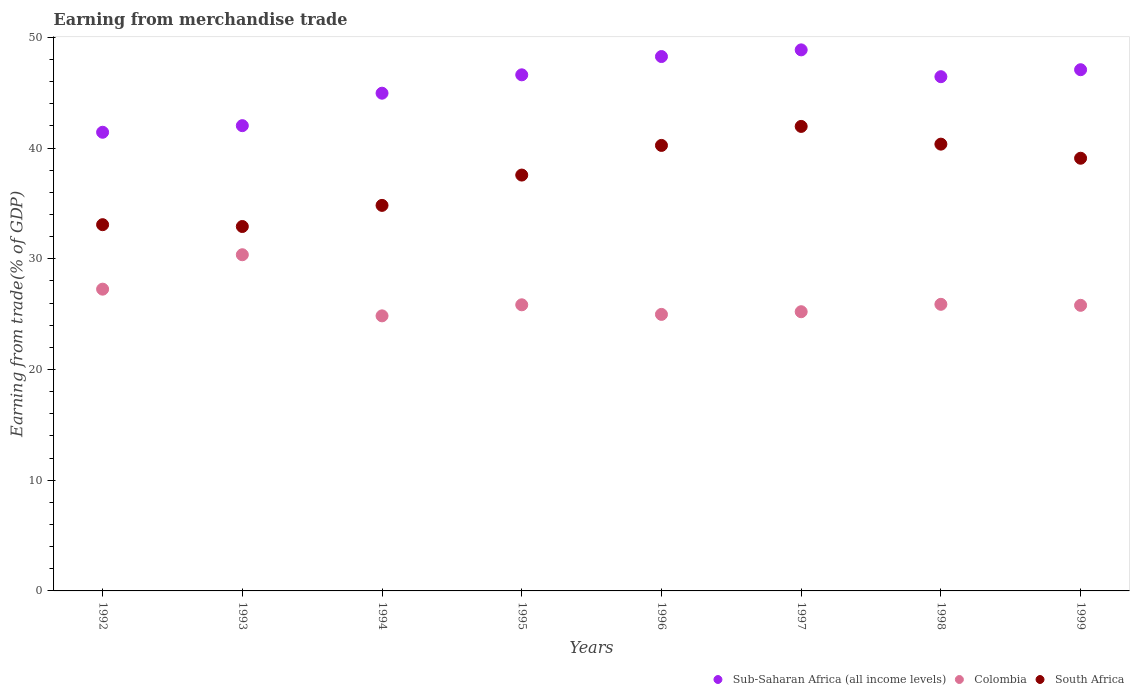What is the earnings from trade in Sub-Saharan Africa (all income levels) in 1996?
Provide a succinct answer. 48.27. Across all years, what is the maximum earnings from trade in Colombia?
Your answer should be compact. 30.37. Across all years, what is the minimum earnings from trade in Colombia?
Your answer should be very brief. 24.85. In which year was the earnings from trade in Colombia maximum?
Offer a very short reply. 1993. What is the total earnings from trade in South Africa in the graph?
Your response must be concise. 300.04. What is the difference between the earnings from trade in Colombia in 1994 and that in 1995?
Offer a terse response. -1. What is the difference between the earnings from trade in South Africa in 1997 and the earnings from trade in Colombia in 1996?
Keep it short and to the point. 16.98. What is the average earnings from trade in Sub-Saharan Africa (all income levels) per year?
Your answer should be compact. 45.71. In the year 1996, what is the difference between the earnings from trade in Sub-Saharan Africa (all income levels) and earnings from trade in Colombia?
Provide a succinct answer. 23.29. In how many years, is the earnings from trade in South Africa greater than 4 %?
Offer a terse response. 8. What is the ratio of the earnings from trade in Sub-Saharan Africa (all income levels) in 1992 to that in 1995?
Provide a succinct answer. 0.89. What is the difference between the highest and the second highest earnings from trade in South Africa?
Provide a succinct answer. 1.6. What is the difference between the highest and the lowest earnings from trade in Sub-Saharan Africa (all income levels)?
Make the answer very short. 7.44. In how many years, is the earnings from trade in Sub-Saharan Africa (all income levels) greater than the average earnings from trade in Sub-Saharan Africa (all income levels) taken over all years?
Keep it short and to the point. 5. Is it the case that in every year, the sum of the earnings from trade in South Africa and earnings from trade in Sub-Saharan Africa (all income levels)  is greater than the earnings from trade in Colombia?
Offer a terse response. Yes. What is the difference between two consecutive major ticks on the Y-axis?
Give a very brief answer. 10. How many legend labels are there?
Offer a terse response. 3. How are the legend labels stacked?
Keep it short and to the point. Horizontal. What is the title of the graph?
Provide a succinct answer. Earning from merchandise trade. Does "Togo" appear as one of the legend labels in the graph?
Your response must be concise. No. What is the label or title of the X-axis?
Keep it short and to the point. Years. What is the label or title of the Y-axis?
Provide a succinct answer. Earning from trade(% of GDP). What is the Earning from trade(% of GDP) in Sub-Saharan Africa (all income levels) in 1992?
Your answer should be compact. 41.43. What is the Earning from trade(% of GDP) in Colombia in 1992?
Make the answer very short. 27.26. What is the Earning from trade(% of GDP) in South Africa in 1992?
Your answer should be compact. 33.08. What is the Earning from trade(% of GDP) of Sub-Saharan Africa (all income levels) in 1993?
Your answer should be compact. 42.03. What is the Earning from trade(% of GDP) in Colombia in 1993?
Offer a terse response. 30.37. What is the Earning from trade(% of GDP) of South Africa in 1993?
Offer a very short reply. 32.92. What is the Earning from trade(% of GDP) in Sub-Saharan Africa (all income levels) in 1994?
Your answer should be compact. 44.96. What is the Earning from trade(% of GDP) in Colombia in 1994?
Offer a very short reply. 24.85. What is the Earning from trade(% of GDP) of South Africa in 1994?
Provide a short and direct response. 34.83. What is the Earning from trade(% of GDP) of Sub-Saharan Africa (all income levels) in 1995?
Your answer should be very brief. 46.62. What is the Earning from trade(% of GDP) in Colombia in 1995?
Provide a succinct answer. 25.85. What is the Earning from trade(% of GDP) of South Africa in 1995?
Your answer should be compact. 37.57. What is the Earning from trade(% of GDP) in Sub-Saharan Africa (all income levels) in 1996?
Make the answer very short. 48.27. What is the Earning from trade(% of GDP) of Colombia in 1996?
Make the answer very short. 24.98. What is the Earning from trade(% of GDP) of South Africa in 1996?
Make the answer very short. 40.24. What is the Earning from trade(% of GDP) of Sub-Saharan Africa (all income levels) in 1997?
Provide a short and direct response. 48.87. What is the Earning from trade(% of GDP) of Colombia in 1997?
Offer a very short reply. 25.22. What is the Earning from trade(% of GDP) in South Africa in 1997?
Offer a very short reply. 41.96. What is the Earning from trade(% of GDP) of Sub-Saharan Africa (all income levels) in 1998?
Offer a terse response. 46.45. What is the Earning from trade(% of GDP) of Colombia in 1998?
Give a very brief answer. 25.89. What is the Earning from trade(% of GDP) in South Africa in 1998?
Provide a short and direct response. 40.36. What is the Earning from trade(% of GDP) in Sub-Saharan Africa (all income levels) in 1999?
Provide a short and direct response. 47.08. What is the Earning from trade(% of GDP) of Colombia in 1999?
Your answer should be compact. 25.8. What is the Earning from trade(% of GDP) of South Africa in 1999?
Provide a short and direct response. 39.09. Across all years, what is the maximum Earning from trade(% of GDP) in Sub-Saharan Africa (all income levels)?
Your response must be concise. 48.87. Across all years, what is the maximum Earning from trade(% of GDP) of Colombia?
Make the answer very short. 30.37. Across all years, what is the maximum Earning from trade(% of GDP) of South Africa?
Your answer should be very brief. 41.96. Across all years, what is the minimum Earning from trade(% of GDP) in Sub-Saharan Africa (all income levels)?
Ensure brevity in your answer.  41.43. Across all years, what is the minimum Earning from trade(% of GDP) in Colombia?
Provide a short and direct response. 24.85. Across all years, what is the minimum Earning from trade(% of GDP) of South Africa?
Keep it short and to the point. 32.92. What is the total Earning from trade(% of GDP) of Sub-Saharan Africa (all income levels) in the graph?
Provide a short and direct response. 365.72. What is the total Earning from trade(% of GDP) in Colombia in the graph?
Provide a short and direct response. 210.21. What is the total Earning from trade(% of GDP) of South Africa in the graph?
Make the answer very short. 300.04. What is the difference between the Earning from trade(% of GDP) of Sub-Saharan Africa (all income levels) in 1992 and that in 1993?
Your response must be concise. -0.6. What is the difference between the Earning from trade(% of GDP) of Colombia in 1992 and that in 1993?
Make the answer very short. -3.11. What is the difference between the Earning from trade(% of GDP) in South Africa in 1992 and that in 1993?
Make the answer very short. 0.16. What is the difference between the Earning from trade(% of GDP) in Sub-Saharan Africa (all income levels) in 1992 and that in 1994?
Ensure brevity in your answer.  -3.53. What is the difference between the Earning from trade(% of GDP) in Colombia in 1992 and that in 1994?
Provide a short and direct response. 2.41. What is the difference between the Earning from trade(% of GDP) in South Africa in 1992 and that in 1994?
Your answer should be compact. -1.74. What is the difference between the Earning from trade(% of GDP) in Sub-Saharan Africa (all income levels) in 1992 and that in 1995?
Offer a terse response. -5.19. What is the difference between the Earning from trade(% of GDP) of Colombia in 1992 and that in 1995?
Ensure brevity in your answer.  1.41. What is the difference between the Earning from trade(% of GDP) in South Africa in 1992 and that in 1995?
Give a very brief answer. -4.48. What is the difference between the Earning from trade(% of GDP) of Sub-Saharan Africa (all income levels) in 1992 and that in 1996?
Give a very brief answer. -6.84. What is the difference between the Earning from trade(% of GDP) in Colombia in 1992 and that in 1996?
Provide a succinct answer. 2.28. What is the difference between the Earning from trade(% of GDP) in South Africa in 1992 and that in 1996?
Your answer should be compact. -7.16. What is the difference between the Earning from trade(% of GDP) in Sub-Saharan Africa (all income levels) in 1992 and that in 1997?
Give a very brief answer. -7.44. What is the difference between the Earning from trade(% of GDP) in Colombia in 1992 and that in 1997?
Keep it short and to the point. 2.04. What is the difference between the Earning from trade(% of GDP) in South Africa in 1992 and that in 1997?
Ensure brevity in your answer.  -8.88. What is the difference between the Earning from trade(% of GDP) in Sub-Saharan Africa (all income levels) in 1992 and that in 1998?
Your answer should be compact. -5.02. What is the difference between the Earning from trade(% of GDP) in Colombia in 1992 and that in 1998?
Provide a short and direct response. 1.37. What is the difference between the Earning from trade(% of GDP) in South Africa in 1992 and that in 1998?
Keep it short and to the point. -7.28. What is the difference between the Earning from trade(% of GDP) in Sub-Saharan Africa (all income levels) in 1992 and that in 1999?
Keep it short and to the point. -5.65. What is the difference between the Earning from trade(% of GDP) of Colombia in 1992 and that in 1999?
Offer a very short reply. 1.46. What is the difference between the Earning from trade(% of GDP) of South Africa in 1992 and that in 1999?
Keep it short and to the point. -6. What is the difference between the Earning from trade(% of GDP) of Sub-Saharan Africa (all income levels) in 1993 and that in 1994?
Provide a succinct answer. -2.93. What is the difference between the Earning from trade(% of GDP) of Colombia in 1993 and that in 1994?
Keep it short and to the point. 5.52. What is the difference between the Earning from trade(% of GDP) in South Africa in 1993 and that in 1994?
Your response must be concise. -1.91. What is the difference between the Earning from trade(% of GDP) of Sub-Saharan Africa (all income levels) in 1993 and that in 1995?
Provide a succinct answer. -4.59. What is the difference between the Earning from trade(% of GDP) of Colombia in 1993 and that in 1995?
Offer a terse response. 4.52. What is the difference between the Earning from trade(% of GDP) of South Africa in 1993 and that in 1995?
Your answer should be compact. -4.65. What is the difference between the Earning from trade(% of GDP) of Sub-Saharan Africa (all income levels) in 1993 and that in 1996?
Your response must be concise. -6.24. What is the difference between the Earning from trade(% of GDP) of Colombia in 1993 and that in 1996?
Provide a short and direct response. 5.39. What is the difference between the Earning from trade(% of GDP) in South Africa in 1993 and that in 1996?
Your response must be concise. -7.33. What is the difference between the Earning from trade(% of GDP) of Sub-Saharan Africa (all income levels) in 1993 and that in 1997?
Provide a succinct answer. -6.85. What is the difference between the Earning from trade(% of GDP) of Colombia in 1993 and that in 1997?
Offer a very short reply. 5.15. What is the difference between the Earning from trade(% of GDP) of South Africa in 1993 and that in 1997?
Make the answer very short. -9.04. What is the difference between the Earning from trade(% of GDP) in Sub-Saharan Africa (all income levels) in 1993 and that in 1998?
Offer a terse response. -4.42. What is the difference between the Earning from trade(% of GDP) in Colombia in 1993 and that in 1998?
Your answer should be compact. 4.48. What is the difference between the Earning from trade(% of GDP) in South Africa in 1993 and that in 1998?
Ensure brevity in your answer.  -7.44. What is the difference between the Earning from trade(% of GDP) of Sub-Saharan Africa (all income levels) in 1993 and that in 1999?
Provide a succinct answer. -5.05. What is the difference between the Earning from trade(% of GDP) in Colombia in 1993 and that in 1999?
Provide a succinct answer. 4.57. What is the difference between the Earning from trade(% of GDP) in South Africa in 1993 and that in 1999?
Offer a very short reply. -6.17. What is the difference between the Earning from trade(% of GDP) of Sub-Saharan Africa (all income levels) in 1994 and that in 1995?
Provide a succinct answer. -1.66. What is the difference between the Earning from trade(% of GDP) of Colombia in 1994 and that in 1995?
Your answer should be very brief. -1. What is the difference between the Earning from trade(% of GDP) in South Africa in 1994 and that in 1995?
Ensure brevity in your answer.  -2.74. What is the difference between the Earning from trade(% of GDP) of Sub-Saharan Africa (all income levels) in 1994 and that in 1996?
Your answer should be compact. -3.31. What is the difference between the Earning from trade(% of GDP) of Colombia in 1994 and that in 1996?
Provide a short and direct response. -0.13. What is the difference between the Earning from trade(% of GDP) of South Africa in 1994 and that in 1996?
Give a very brief answer. -5.42. What is the difference between the Earning from trade(% of GDP) of Sub-Saharan Africa (all income levels) in 1994 and that in 1997?
Your answer should be very brief. -3.91. What is the difference between the Earning from trade(% of GDP) in Colombia in 1994 and that in 1997?
Your response must be concise. -0.37. What is the difference between the Earning from trade(% of GDP) of South Africa in 1994 and that in 1997?
Your response must be concise. -7.13. What is the difference between the Earning from trade(% of GDP) of Sub-Saharan Africa (all income levels) in 1994 and that in 1998?
Keep it short and to the point. -1.49. What is the difference between the Earning from trade(% of GDP) in Colombia in 1994 and that in 1998?
Provide a short and direct response. -1.04. What is the difference between the Earning from trade(% of GDP) of South Africa in 1994 and that in 1998?
Your answer should be compact. -5.53. What is the difference between the Earning from trade(% of GDP) in Sub-Saharan Africa (all income levels) in 1994 and that in 1999?
Offer a terse response. -2.12. What is the difference between the Earning from trade(% of GDP) of Colombia in 1994 and that in 1999?
Your response must be concise. -0.95. What is the difference between the Earning from trade(% of GDP) of South Africa in 1994 and that in 1999?
Offer a very short reply. -4.26. What is the difference between the Earning from trade(% of GDP) of Sub-Saharan Africa (all income levels) in 1995 and that in 1996?
Ensure brevity in your answer.  -1.65. What is the difference between the Earning from trade(% of GDP) of Colombia in 1995 and that in 1996?
Your answer should be very brief. 0.87. What is the difference between the Earning from trade(% of GDP) in South Africa in 1995 and that in 1996?
Your response must be concise. -2.68. What is the difference between the Earning from trade(% of GDP) in Sub-Saharan Africa (all income levels) in 1995 and that in 1997?
Offer a very short reply. -2.25. What is the difference between the Earning from trade(% of GDP) of Colombia in 1995 and that in 1997?
Your response must be concise. 0.63. What is the difference between the Earning from trade(% of GDP) of South Africa in 1995 and that in 1997?
Provide a succinct answer. -4.39. What is the difference between the Earning from trade(% of GDP) in Sub-Saharan Africa (all income levels) in 1995 and that in 1998?
Give a very brief answer. 0.17. What is the difference between the Earning from trade(% of GDP) in Colombia in 1995 and that in 1998?
Keep it short and to the point. -0.04. What is the difference between the Earning from trade(% of GDP) of South Africa in 1995 and that in 1998?
Offer a very short reply. -2.79. What is the difference between the Earning from trade(% of GDP) of Sub-Saharan Africa (all income levels) in 1995 and that in 1999?
Offer a terse response. -0.46. What is the difference between the Earning from trade(% of GDP) in Colombia in 1995 and that in 1999?
Offer a very short reply. 0.05. What is the difference between the Earning from trade(% of GDP) in South Africa in 1995 and that in 1999?
Make the answer very short. -1.52. What is the difference between the Earning from trade(% of GDP) in Sub-Saharan Africa (all income levels) in 1996 and that in 1997?
Keep it short and to the point. -0.6. What is the difference between the Earning from trade(% of GDP) of Colombia in 1996 and that in 1997?
Provide a succinct answer. -0.24. What is the difference between the Earning from trade(% of GDP) in South Africa in 1996 and that in 1997?
Your response must be concise. -1.72. What is the difference between the Earning from trade(% of GDP) of Sub-Saharan Africa (all income levels) in 1996 and that in 1998?
Your answer should be very brief. 1.82. What is the difference between the Earning from trade(% of GDP) in Colombia in 1996 and that in 1998?
Give a very brief answer. -0.91. What is the difference between the Earning from trade(% of GDP) in South Africa in 1996 and that in 1998?
Provide a succinct answer. -0.11. What is the difference between the Earning from trade(% of GDP) of Sub-Saharan Africa (all income levels) in 1996 and that in 1999?
Your answer should be very brief. 1.19. What is the difference between the Earning from trade(% of GDP) of Colombia in 1996 and that in 1999?
Make the answer very short. -0.82. What is the difference between the Earning from trade(% of GDP) of South Africa in 1996 and that in 1999?
Ensure brevity in your answer.  1.16. What is the difference between the Earning from trade(% of GDP) in Sub-Saharan Africa (all income levels) in 1997 and that in 1998?
Your answer should be very brief. 2.42. What is the difference between the Earning from trade(% of GDP) in Colombia in 1997 and that in 1998?
Your answer should be very brief. -0.67. What is the difference between the Earning from trade(% of GDP) of South Africa in 1997 and that in 1998?
Your answer should be compact. 1.6. What is the difference between the Earning from trade(% of GDP) in Sub-Saharan Africa (all income levels) in 1997 and that in 1999?
Offer a terse response. 1.79. What is the difference between the Earning from trade(% of GDP) of Colombia in 1997 and that in 1999?
Make the answer very short. -0.58. What is the difference between the Earning from trade(% of GDP) of South Africa in 1997 and that in 1999?
Your response must be concise. 2.87. What is the difference between the Earning from trade(% of GDP) of Sub-Saharan Africa (all income levels) in 1998 and that in 1999?
Provide a succinct answer. -0.63. What is the difference between the Earning from trade(% of GDP) of Colombia in 1998 and that in 1999?
Keep it short and to the point. 0.09. What is the difference between the Earning from trade(% of GDP) in South Africa in 1998 and that in 1999?
Provide a short and direct response. 1.27. What is the difference between the Earning from trade(% of GDP) of Sub-Saharan Africa (all income levels) in 1992 and the Earning from trade(% of GDP) of Colombia in 1993?
Offer a very short reply. 11.06. What is the difference between the Earning from trade(% of GDP) of Sub-Saharan Africa (all income levels) in 1992 and the Earning from trade(% of GDP) of South Africa in 1993?
Give a very brief answer. 8.51. What is the difference between the Earning from trade(% of GDP) of Colombia in 1992 and the Earning from trade(% of GDP) of South Africa in 1993?
Ensure brevity in your answer.  -5.66. What is the difference between the Earning from trade(% of GDP) in Sub-Saharan Africa (all income levels) in 1992 and the Earning from trade(% of GDP) in Colombia in 1994?
Ensure brevity in your answer.  16.59. What is the difference between the Earning from trade(% of GDP) in Sub-Saharan Africa (all income levels) in 1992 and the Earning from trade(% of GDP) in South Africa in 1994?
Keep it short and to the point. 6.61. What is the difference between the Earning from trade(% of GDP) in Colombia in 1992 and the Earning from trade(% of GDP) in South Africa in 1994?
Your answer should be very brief. -7.57. What is the difference between the Earning from trade(% of GDP) in Sub-Saharan Africa (all income levels) in 1992 and the Earning from trade(% of GDP) in Colombia in 1995?
Offer a very short reply. 15.59. What is the difference between the Earning from trade(% of GDP) of Sub-Saharan Africa (all income levels) in 1992 and the Earning from trade(% of GDP) of South Africa in 1995?
Give a very brief answer. 3.87. What is the difference between the Earning from trade(% of GDP) of Colombia in 1992 and the Earning from trade(% of GDP) of South Africa in 1995?
Keep it short and to the point. -10.31. What is the difference between the Earning from trade(% of GDP) in Sub-Saharan Africa (all income levels) in 1992 and the Earning from trade(% of GDP) in Colombia in 1996?
Your response must be concise. 16.45. What is the difference between the Earning from trade(% of GDP) in Sub-Saharan Africa (all income levels) in 1992 and the Earning from trade(% of GDP) in South Africa in 1996?
Offer a very short reply. 1.19. What is the difference between the Earning from trade(% of GDP) in Colombia in 1992 and the Earning from trade(% of GDP) in South Africa in 1996?
Keep it short and to the point. -12.98. What is the difference between the Earning from trade(% of GDP) of Sub-Saharan Africa (all income levels) in 1992 and the Earning from trade(% of GDP) of Colombia in 1997?
Provide a short and direct response. 16.21. What is the difference between the Earning from trade(% of GDP) of Sub-Saharan Africa (all income levels) in 1992 and the Earning from trade(% of GDP) of South Africa in 1997?
Make the answer very short. -0.53. What is the difference between the Earning from trade(% of GDP) of Colombia in 1992 and the Earning from trade(% of GDP) of South Africa in 1997?
Your answer should be very brief. -14.7. What is the difference between the Earning from trade(% of GDP) in Sub-Saharan Africa (all income levels) in 1992 and the Earning from trade(% of GDP) in Colombia in 1998?
Make the answer very short. 15.54. What is the difference between the Earning from trade(% of GDP) in Sub-Saharan Africa (all income levels) in 1992 and the Earning from trade(% of GDP) in South Africa in 1998?
Your response must be concise. 1.07. What is the difference between the Earning from trade(% of GDP) of Colombia in 1992 and the Earning from trade(% of GDP) of South Africa in 1998?
Offer a terse response. -13.1. What is the difference between the Earning from trade(% of GDP) of Sub-Saharan Africa (all income levels) in 1992 and the Earning from trade(% of GDP) of Colombia in 1999?
Make the answer very short. 15.63. What is the difference between the Earning from trade(% of GDP) of Sub-Saharan Africa (all income levels) in 1992 and the Earning from trade(% of GDP) of South Africa in 1999?
Offer a very short reply. 2.35. What is the difference between the Earning from trade(% of GDP) in Colombia in 1992 and the Earning from trade(% of GDP) in South Africa in 1999?
Make the answer very short. -11.83. What is the difference between the Earning from trade(% of GDP) of Sub-Saharan Africa (all income levels) in 1993 and the Earning from trade(% of GDP) of Colombia in 1994?
Make the answer very short. 17.18. What is the difference between the Earning from trade(% of GDP) of Sub-Saharan Africa (all income levels) in 1993 and the Earning from trade(% of GDP) of South Africa in 1994?
Offer a terse response. 7.2. What is the difference between the Earning from trade(% of GDP) of Colombia in 1993 and the Earning from trade(% of GDP) of South Africa in 1994?
Your answer should be compact. -4.46. What is the difference between the Earning from trade(% of GDP) of Sub-Saharan Africa (all income levels) in 1993 and the Earning from trade(% of GDP) of Colombia in 1995?
Your response must be concise. 16.18. What is the difference between the Earning from trade(% of GDP) in Sub-Saharan Africa (all income levels) in 1993 and the Earning from trade(% of GDP) in South Africa in 1995?
Your answer should be very brief. 4.46. What is the difference between the Earning from trade(% of GDP) of Colombia in 1993 and the Earning from trade(% of GDP) of South Africa in 1995?
Give a very brief answer. -7.2. What is the difference between the Earning from trade(% of GDP) in Sub-Saharan Africa (all income levels) in 1993 and the Earning from trade(% of GDP) in Colombia in 1996?
Your answer should be compact. 17.05. What is the difference between the Earning from trade(% of GDP) in Sub-Saharan Africa (all income levels) in 1993 and the Earning from trade(% of GDP) in South Africa in 1996?
Your answer should be compact. 1.78. What is the difference between the Earning from trade(% of GDP) in Colombia in 1993 and the Earning from trade(% of GDP) in South Africa in 1996?
Your answer should be compact. -9.88. What is the difference between the Earning from trade(% of GDP) in Sub-Saharan Africa (all income levels) in 1993 and the Earning from trade(% of GDP) in Colombia in 1997?
Offer a terse response. 16.81. What is the difference between the Earning from trade(% of GDP) of Sub-Saharan Africa (all income levels) in 1993 and the Earning from trade(% of GDP) of South Africa in 1997?
Your response must be concise. 0.07. What is the difference between the Earning from trade(% of GDP) of Colombia in 1993 and the Earning from trade(% of GDP) of South Africa in 1997?
Make the answer very short. -11.59. What is the difference between the Earning from trade(% of GDP) in Sub-Saharan Africa (all income levels) in 1993 and the Earning from trade(% of GDP) in Colombia in 1998?
Offer a very short reply. 16.14. What is the difference between the Earning from trade(% of GDP) of Sub-Saharan Africa (all income levels) in 1993 and the Earning from trade(% of GDP) of South Africa in 1998?
Your answer should be compact. 1.67. What is the difference between the Earning from trade(% of GDP) in Colombia in 1993 and the Earning from trade(% of GDP) in South Africa in 1998?
Your answer should be compact. -9.99. What is the difference between the Earning from trade(% of GDP) of Sub-Saharan Africa (all income levels) in 1993 and the Earning from trade(% of GDP) of Colombia in 1999?
Provide a short and direct response. 16.23. What is the difference between the Earning from trade(% of GDP) in Sub-Saharan Africa (all income levels) in 1993 and the Earning from trade(% of GDP) in South Africa in 1999?
Provide a succinct answer. 2.94. What is the difference between the Earning from trade(% of GDP) in Colombia in 1993 and the Earning from trade(% of GDP) in South Africa in 1999?
Offer a very short reply. -8.72. What is the difference between the Earning from trade(% of GDP) of Sub-Saharan Africa (all income levels) in 1994 and the Earning from trade(% of GDP) of Colombia in 1995?
Make the answer very short. 19.11. What is the difference between the Earning from trade(% of GDP) of Sub-Saharan Africa (all income levels) in 1994 and the Earning from trade(% of GDP) of South Africa in 1995?
Ensure brevity in your answer.  7.39. What is the difference between the Earning from trade(% of GDP) of Colombia in 1994 and the Earning from trade(% of GDP) of South Africa in 1995?
Give a very brief answer. -12.72. What is the difference between the Earning from trade(% of GDP) in Sub-Saharan Africa (all income levels) in 1994 and the Earning from trade(% of GDP) in Colombia in 1996?
Offer a terse response. 19.98. What is the difference between the Earning from trade(% of GDP) of Sub-Saharan Africa (all income levels) in 1994 and the Earning from trade(% of GDP) of South Africa in 1996?
Your answer should be very brief. 4.72. What is the difference between the Earning from trade(% of GDP) in Colombia in 1994 and the Earning from trade(% of GDP) in South Africa in 1996?
Ensure brevity in your answer.  -15.4. What is the difference between the Earning from trade(% of GDP) of Sub-Saharan Africa (all income levels) in 1994 and the Earning from trade(% of GDP) of Colombia in 1997?
Offer a very short reply. 19.74. What is the difference between the Earning from trade(% of GDP) of Sub-Saharan Africa (all income levels) in 1994 and the Earning from trade(% of GDP) of South Africa in 1997?
Your answer should be compact. 3. What is the difference between the Earning from trade(% of GDP) in Colombia in 1994 and the Earning from trade(% of GDP) in South Africa in 1997?
Your answer should be compact. -17.11. What is the difference between the Earning from trade(% of GDP) of Sub-Saharan Africa (all income levels) in 1994 and the Earning from trade(% of GDP) of Colombia in 1998?
Offer a very short reply. 19.07. What is the difference between the Earning from trade(% of GDP) of Sub-Saharan Africa (all income levels) in 1994 and the Earning from trade(% of GDP) of South Africa in 1998?
Make the answer very short. 4.6. What is the difference between the Earning from trade(% of GDP) of Colombia in 1994 and the Earning from trade(% of GDP) of South Africa in 1998?
Your answer should be very brief. -15.51. What is the difference between the Earning from trade(% of GDP) in Sub-Saharan Africa (all income levels) in 1994 and the Earning from trade(% of GDP) in Colombia in 1999?
Offer a very short reply. 19.16. What is the difference between the Earning from trade(% of GDP) of Sub-Saharan Africa (all income levels) in 1994 and the Earning from trade(% of GDP) of South Africa in 1999?
Keep it short and to the point. 5.88. What is the difference between the Earning from trade(% of GDP) of Colombia in 1994 and the Earning from trade(% of GDP) of South Africa in 1999?
Your answer should be very brief. -14.24. What is the difference between the Earning from trade(% of GDP) in Sub-Saharan Africa (all income levels) in 1995 and the Earning from trade(% of GDP) in Colombia in 1996?
Provide a succinct answer. 21.64. What is the difference between the Earning from trade(% of GDP) of Sub-Saharan Africa (all income levels) in 1995 and the Earning from trade(% of GDP) of South Africa in 1996?
Make the answer very short. 6.38. What is the difference between the Earning from trade(% of GDP) in Colombia in 1995 and the Earning from trade(% of GDP) in South Africa in 1996?
Keep it short and to the point. -14.4. What is the difference between the Earning from trade(% of GDP) in Sub-Saharan Africa (all income levels) in 1995 and the Earning from trade(% of GDP) in Colombia in 1997?
Offer a very short reply. 21.4. What is the difference between the Earning from trade(% of GDP) in Sub-Saharan Africa (all income levels) in 1995 and the Earning from trade(% of GDP) in South Africa in 1997?
Offer a very short reply. 4.66. What is the difference between the Earning from trade(% of GDP) in Colombia in 1995 and the Earning from trade(% of GDP) in South Africa in 1997?
Give a very brief answer. -16.11. What is the difference between the Earning from trade(% of GDP) in Sub-Saharan Africa (all income levels) in 1995 and the Earning from trade(% of GDP) in Colombia in 1998?
Your response must be concise. 20.73. What is the difference between the Earning from trade(% of GDP) in Sub-Saharan Africa (all income levels) in 1995 and the Earning from trade(% of GDP) in South Africa in 1998?
Offer a very short reply. 6.26. What is the difference between the Earning from trade(% of GDP) of Colombia in 1995 and the Earning from trade(% of GDP) of South Africa in 1998?
Provide a succinct answer. -14.51. What is the difference between the Earning from trade(% of GDP) of Sub-Saharan Africa (all income levels) in 1995 and the Earning from trade(% of GDP) of Colombia in 1999?
Provide a short and direct response. 20.82. What is the difference between the Earning from trade(% of GDP) of Sub-Saharan Africa (all income levels) in 1995 and the Earning from trade(% of GDP) of South Africa in 1999?
Your answer should be compact. 7.53. What is the difference between the Earning from trade(% of GDP) in Colombia in 1995 and the Earning from trade(% of GDP) in South Africa in 1999?
Your response must be concise. -13.24. What is the difference between the Earning from trade(% of GDP) in Sub-Saharan Africa (all income levels) in 1996 and the Earning from trade(% of GDP) in Colombia in 1997?
Your answer should be very brief. 23.05. What is the difference between the Earning from trade(% of GDP) in Sub-Saharan Africa (all income levels) in 1996 and the Earning from trade(% of GDP) in South Africa in 1997?
Ensure brevity in your answer.  6.31. What is the difference between the Earning from trade(% of GDP) of Colombia in 1996 and the Earning from trade(% of GDP) of South Africa in 1997?
Offer a very short reply. -16.98. What is the difference between the Earning from trade(% of GDP) in Sub-Saharan Africa (all income levels) in 1996 and the Earning from trade(% of GDP) in Colombia in 1998?
Ensure brevity in your answer.  22.38. What is the difference between the Earning from trade(% of GDP) of Sub-Saharan Africa (all income levels) in 1996 and the Earning from trade(% of GDP) of South Africa in 1998?
Provide a succinct answer. 7.91. What is the difference between the Earning from trade(% of GDP) in Colombia in 1996 and the Earning from trade(% of GDP) in South Africa in 1998?
Offer a very short reply. -15.38. What is the difference between the Earning from trade(% of GDP) in Sub-Saharan Africa (all income levels) in 1996 and the Earning from trade(% of GDP) in Colombia in 1999?
Your response must be concise. 22.47. What is the difference between the Earning from trade(% of GDP) of Sub-Saharan Africa (all income levels) in 1996 and the Earning from trade(% of GDP) of South Africa in 1999?
Your answer should be very brief. 9.19. What is the difference between the Earning from trade(% of GDP) in Colombia in 1996 and the Earning from trade(% of GDP) in South Africa in 1999?
Provide a short and direct response. -14.11. What is the difference between the Earning from trade(% of GDP) of Sub-Saharan Africa (all income levels) in 1997 and the Earning from trade(% of GDP) of Colombia in 1998?
Ensure brevity in your answer.  22.98. What is the difference between the Earning from trade(% of GDP) of Sub-Saharan Africa (all income levels) in 1997 and the Earning from trade(% of GDP) of South Africa in 1998?
Offer a very short reply. 8.52. What is the difference between the Earning from trade(% of GDP) in Colombia in 1997 and the Earning from trade(% of GDP) in South Africa in 1998?
Ensure brevity in your answer.  -15.14. What is the difference between the Earning from trade(% of GDP) in Sub-Saharan Africa (all income levels) in 1997 and the Earning from trade(% of GDP) in Colombia in 1999?
Give a very brief answer. 23.08. What is the difference between the Earning from trade(% of GDP) of Sub-Saharan Africa (all income levels) in 1997 and the Earning from trade(% of GDP) of South Africa in 1999?
Provide a short and direct response. 9.79. What is the difference between the Earning from trade(% of GDP) in Colombia in 1997 and the Earning from trade(% of GDP) in South Africa in 1999?
Give a very brief answer. -13.86. What is the difference between the Earning from trade(% of GDP) of Sub-Saharan Africa (all income levels) in 1998 and the Earning from trade(% of GDP) of Colombia in 1999?
Your response must be concise. 20.65. What is the difference between the Earning from trade(% of GDP) in Sub-Saharan Africa (all income levels) in 1998 and the Earning from trade(% of GDP) in South Africa in 1999?
Your answer should be compact. 7.37. What is the difference between the Earning from trade(% of GDP) of Colombia in 1998 and the Earning from trade(% of GDP) of South Africa in 1999?
Your answer should be very brief. -13.2. What is the average Earning from trade(% of GDP) in Sub-Saharan Africa (all income levels) per year?
Ensure brevity in your answer.  45.71. What is the average Earning from trade(% of GDP) in Colombia per year?
Offer a terse response. 26.28. What is the average Earning from trade(% of GDP) in South Africa per year?
Your response must be concise. 37.51. In the year 1992, what is the difference between the Earning from trade(% of GDP) in Sub-Saharan Africa (all income levels) and Earning from trade(% of GDP) in Colombia?
Offer a very short reply. 14.17. In the year 1992, what is the difference between the Earning from trade(% of GDP) of Sub-Saharan Africa (all income levels) and Earning from trade(% of GDP) of South Africa?
Keep it short and to the point. 8.35. In the year 1992, what is the difference between the Earning from trade(% of GDP) of Colombia and Earning from trade(% of GDP) of South Africa?
Offer a terse response. -5.82. In the year 1993, what is the difference between the Earning from trade(% of GDP) of Sub-Saharan Africa (all income levels) and Earning from trade(% of GDP) of Colombia?
Give a very brief answer. 11.66. In the year 1993, what is the difference between the Earning from trade(% of GDP) of Sub-Saharan Africa (all income levels) and Earning from trade(% of GDP) of South Africa?
Give a very brief answer. 9.11. In the year 1993, what is the difference between the Earning from trade(% of GDP) in Colombia and Earning from trade(% of GDP) in South Africa?
Ensure brevity in your answer.  -2.55. In the year 1994, what is the difference between the Earning from trade(% of GDP) of Sub-Saharan Africa (all income levels) and Earning from trade(% of GDP) of Colombia?
Your answer should be very brief. 20.11. In the year 1994, what is the difference between the Earning from trade(% of GDP) in Sub-Saharan Africa (all income levels) and Earning from trade(% of GDP) in South Africa?
Your response must be concise. 10.13. In the year 1994, what is the difference between the Earning from trade(% of GDP) of Colombia and Earning from trade(% of GDP) of South Africa?
Make the answer very short. -9.98. In the year 1995, what is the difference between the Earning from trade(% of GDP) of Sub-Saharan Africa (all income levels) and Earning from trade(% of GDP) of Colombia?
Keep it short and to the point. 20.77. In the year 1995, what is the difference between the Earning from trade(% of GDP) of Sub-Saharan Africa (all income levels) and Earning from trade(% of GDP) of South Africa?
Make the answer very short. 9.05. In the year 1995, what is the difference between the Earning from trade(% of GDP) in Colombia and Earning from trade(% of GDP) in South Africa?
Provide a succinct answer. -11.72. In the year 1996, what is the difference between the Earning from trade(% of GDP) of Sub-Saharan Africa (all income levels) and Earning from trade(% of GDP) of Colombia?
Provide a succinct answer. 23.29. In the year 1996, what is the difference between the Earning from trade(% of GDP) of Sub-Saharan Africa (all income levels) and Earning from trade(% of GDP) of South Africa?
Make the answer very short. 8.03. In the year 1996, what is the difference between the Earning from trade(% of GDP) of Colombia and Earning from trade(% of GDP) of South Africa?
Your response must be concise. -15.26. In the year 1997, what is the difference between the Earning from trade(% of GDP) in Sub-Saharan Africa (all income levels) and Earning from trade(% of GDP) in Colombia?
Offer a very short reply. 23.65. In the year 1997, what is the difference between the Earning from trade(% of GDP) of Sub-Saharan Africa (all income levels) and Earning from trade(% of GDP) of South Africa?
Your answer should be very brief. 6.91. In the year 1997, what is the difference between the Earning from trade(% of GDP) in Colombia and Earning from trade(% of GDP) in South Africa?
Your response must be concise. -16.74. In the year 1998, what is the difference between the Earning from trade(% of GDP) in Sub-Saharan Africa (all income levels) and Earning from trade(% of GDP) in Colombia?
Offer a terse response. 20.56. In the year 1998, what is the difference between the Earning from trade(% of GDP) in Sub-Saharan Africa (all income levels) and Earning from trade(% of GDP) in South Africa?
Provide a short and direct response. 6.09. In the year 1998, what is the difference between the Earning from trade(% of GDP) in Colombia and Earning from trade(% of GDP) in South Africa?
Your answer should be very brief. -14.47. In the year 1999, what is the difference between the Earning from trade(% of GDP) of Sub-Saharan Africa (all income levels) and Earning from trade(% of GDP) of Colombia?
Provide a succinct answer. 21.28. In the year 1999, what is the difference between the Earning from trade(% of GDP) of Sub-Saharan Africa (all income levels) and Earning from trade(% of GDP) of South Africa?
Your answer should be very brief. 8. In the year 1999, what is the difference between the Earning from trade(% of GDP) of Colombia and Earning from trade(% of GDP) of South Africa?
Offer a terse response. -13.29. What is the ratio of the Earning from trade(% of GDP) of Sub-Saharan Africa (all income levels) in 1992 to that in 1993?
Give a very brief answer. 0.99. What is the ratio of the Earning from trade(% of GDP) in Colombia in 1992 to that in 1993?
Keep it short and to the point. 0.9. What is the ratio of the Earning from trade(% of GDP) of South Africa in 1992 to that in 1993?
Provide a short and direct response. 1. What is the ratio of the Earning from trade(% of GDP) in Sub-Saharan Africa (all income levels) in 1992 to that in 1994?
Keep it short and to the point. 0.92. What is the ratio of the Earning from trade(% of GDP) of Colombia in 1992 to that in 1994?
Your response must be concise. 1.1. What is the ratio of the Earning from trade(% of GDP) of South Africa in 1992 to that in 1994?
Your answer should be very brief. 0.95. What is the ratio of the Earning from trade(% of GDP) of Sub-Saharan Africa (all income levels) in 1992 to that in 1995?
Ensure brevity in your answer.  0.89. What is the ratio of the Earning from trade(% of GDP) of Colombia in 1992 to that in 1995?
Keep it short and to the point. 1.05. What is the ratio of the Earning from trade(% of GDP) in South Africa in 1992 to that in 1995?
Ensure brevity in your answer.  0.88. What is the ratio of the Earning from trade(% of GDP) of Sub-Saharan Africa (all income levels) in 1992 to that in 1996?
Offer a terse response. 0.86. What is the ratio of the Earning from trade(% of GDP) of Colombia in 1992 to that in 1996?
Offer a terse response. 1.09. What is the ratio of the Earning from trade(% of GDP) in South Africa in 1992 to that in 1996?
Make the answer very short. 0.82. What is the ratio of the Earning from trade(% of GDP) of Sub-Saharan Africa (all income levels) in 1992 to that in 1997?
Your response must be concise. 0.85. What is the ratio of the Earning from trade(% of GDP) in Colombia in 1992 to that in 1997?
Offer a very short reply. 1.08. What is the ratio of the Earning from trade(% of GDP) of South Africa in 1992 to that in 1997?
Provide a short and direct response. 0.79. What is the ratio of the Earning from trade(% of GDP) of Sub-Saharan Africa (all income levels) in 1992 to that in 1998?
Offer a very short reply. 0.89. What is the ratio of the Earning from trade(% of GDP) in Colombia in 1992 to that in 1998?
Your answer should be very brief. 1.05. What is the ratio of the Earning from trade(% of GDP) of South Africa in 1992 to that in 1998?
Give a very brief answer. 0.82. What is the ratio of the Earning from trade(% of GDP) in Colombia in 1992 to that in 1999?
Your answer should be compact. 1.06. What is the ratio of the Earning from trade(% of GDP) of South Africa in 1992 to that in 1999?
Make the answer very short. 0.85. What is the ratio of the Earning from trade(% of GDP) of Sub-Saharan Africa (all income levels) in 1993 to that in 1994?
Offer a terse response. 0.93. What is the ratio of the Earning from trade(% of GDP) of Colombia in 1993 to that in 1994?
Ensure brevity in your answer.  1.22. What is the ratio of the Earning from trade(% of GDP) in South Africa in 1993 to that in 1994?
Keep it short and to the point. 0.95. What is the ratio of the Earning from trade(% of GDP) of Sub-Saharan Africa (all income levels) in 1993 to that in 1995?
Give a very brief answer. 0.9. What is the ratio of the Earning from trade(% of GDP) in Colombia in 1993 to that in 1995?
Your answer should be very brief. 1.18. What is the ratio of the Earning from trade(% of GDP) of South Africa in 1993 to that in 1995?
Your response must be concise. 0.88. What is the ratio of the Earning from trade(% of GDP) of Sub-Saharan Africa (all income levels) in 1993 to that in 1996?
Offer a very short reply. 0.87. What is the ratio of the Earning from trade(% of GDP) in Colombia in 1993 to that in 1996?
Give a very brief answer. 1.22. What is the ratio of the Earning from trade(% of GDP) in South Africa in 1993 to that in 1996?
Give a very brief answer. 0.82. What is the ratio of the Earning from trade(% of GDP) in Sub-Saharan Africa (all income levels) in 1993 to that in 1997?
Offer a terse response. 0.86. What is the ratio of the Earning from trade(% of GDP) of Colombia in 1993 to that in 1997?
Ensure brevity in your answer.  1.2. What is the ratio of the Earning from trade(% of GDP) of South Africa in 1993 to that in 1997?
Make the answer very short. 0.78. What is the ratio of the Earning from trade(% of GDP) in Sub-Saharan Africa (all income levels) in 1993 to that in 1998?
Make the answer very short. 0.9. What is the ratio of the Earning from trade(% of GDP) of Colombia in 1993 to that in 1998?
Give a very brief answer. 1.17. What is the ratio of the Earning from trade(% of GDP) in South Africa in 1993 to that in 1998?
Keep it short and to the point. 0.82. What is the ratio of the Earning from trade(% of GDP) in Sub-Saharan Africa (all income levels) in 1993 to that in 1999?
Your answer should be compact. 0.89. What is the ratio of the Earning from trade(% of GDP) of Colombia in 1993 to that in 1999?
Keep it short and to the point. 1.18. What is the ratio of the Earning from trade(% of GDP) of South Africa in 1993 to that in 1999?
Your answer should be very brief. 0.84. What is the ratio of the Earning from trade(% of GDP) in Sub-Saharan Africa (all income levels) in 1994 to that in 1995?
Your response must be concise. 0.96. What is the ratio of the Earning from trade(% of GDP) in Colombia in 1994 to that in 1995?
Offer a terse response. 0.96. What is the ratio of the Earning from trade(% of GDP) of South Africa in 1994 to that in 1995?
Make the answer very short. 0.93. What is the ratio of the Earning from trade(% of GDP) in Sub-Saharan Africa (all income levels) in 1994 to that in 1996?
Give a very brief answer. 0.93. What is the ratio of the Earning from trade(% of GDP) in South Africa in 1994 to that in 1996?
Your response must be concise. 0.87. What is the ratio of the Earning from trade(% of GDP) in Sub-Saharan Africa (all income levels) in 1994 to that in 1997?
Ensure brevity in your answer.  0.92. What is the ratio of the Earning from trade(% of GDP) of Colombia in 1994 to that in 1997?
Give a very brief answer. 0.99. What is the ratio of the Earning from trade(% of GDP) of South Africa in 1994 to that in 1997?
Give a very brief answer. 0.83. What is the ratio of the Earning from trade(% of GDP) in Sub-Saharan Africa (all income levels) in 1994 to that in 1998?
Provide a short and direct response. 0.97. What is the ratio of the Earning from trade(% of GDP) of Colombia in 1994 to that in 1998?
Provide a short and direct response. 0.96. What is the ratio of the Earning from trade(% of GDP) in South Africa in 1994 to that in 1998?
Your response must be concise. 0.86. What is the ratio of the Earning from trade(% of GDP) of Sub-Saharan Africa (all income levels) in 1994 to that in 1999?
Your answer should be compact. 0.95. What is the ratio of the Earning from trade(% of GDP) in Colombia in 1994 to that in 1999?
Keep it short and to the point. 0.96. What is the ratio of the Earning from trade(% of GDP) of South Africa in 1994 to that in 1999?
Keep it short and to the point. 0.89. What is the ratio of the Earning from trade(% of GDP) in Sub-Saharan Africa (all income levels) in 1995 to that in 1996?
Offer a terse response. 0.97. What is the ratio of the Earning from trade(% of GDP) in Colombia in 1995 to that in 1996?
Offer a very short reply. 1.03. What is the ratio of the Earning from trade(% of GDP) of South Africa in 1995 to that in 1996?
Give a very brief answer. 0.93. What is the ratio of the Earning from trade(% of GDP) of Sub-Saharan Africa (all income levels) in 1995 to that in 1997?
Give a very brief answer. 0.95. What is the ratio of the Earning from trade(% of GDP) of Colombia in 1995 to that in 1997?
Keep it short and to the point. 1.02. What is the ratio of the Earning from trade(% of GDP) of South Africa in 1995 to that in 1997?
Your answer should be very brief. 0.9. What is the ratio of the Earning from trade(% of GDP) of Sub-Saharan Africa (all income levels) in 1995 to that in 1998?
Provide a succinct answer. 1. What is the ratio of the Earning from trade(% of GDP) of South Africa in 1995 to that in 1998?
Keep it short and to the point. 0.93. What is the ratio of the Earning from trade(% of GDP) of Sub-Saharan Africa (all income levels) in 1995 to that in 1999?
Your answer should be very brief. 0.99. What is the ratio of the Earning from trade(% of GDP) of South Africa in 1995 to that in 1999?
Provide a short and direct response. 0.96. What is the ratio of the Earning from trade(% of GDP) in South Africa in 1996 to that in 1997?
Offer a terse response. 0.96. What is the ratio of the Earning from trade(% of GDP) of Sub-Saharan Africa (all income levels) in 1996 to that in 1998?
Offer a terse response. 1.04. What is the ratio of the Earning from trade(% of GDP) in Colombia in 1996 to that in 1998?
Keep it short and to the point. 0.96. What is the ratio of the Earning from trade(% of GDP) of Sub-Saharan Africa (all income levels) in 1996 to that in 1999?
Give a very brief answer. 1.03. What is the ratio of the Earning from trade(% of GDP) in Colombia in 1996 to that in 1999?
Ensure brevity in your answer.  0.97. What is the ratio of the Earning from trade(% of GDP) of South Africa in 1996 to that in 1999?
Provide a short and direct response. 1.03. What is the ratio of the Earning from trade(% of GDP) of Sub-Saharan Africa (all income levels) in 1997 to that in 1998?
Offer a terse response. 1.05. What is the ratio of the Earning from trade(% of GDP) in Colombia in 1997 to that in 1998?
Your response must be concise. 0.97. What is the ratio of the Earning from trade(% of GDP) in South Africa in 1997 to that in 1998?
Offer a very short reply. 1.04. What is the ratio of the Earning from trade(% of GDP) in Sub-Saharan Africa (all income levels) in 1997 to that in 1999?
Your answer should be very brief. 1.04. What is the ratio of the Earning from trade(% of GDP) of Colombia in 1997 to that in 1999?
Your answer should be very brief. 0.98. What is the ratio of the Earning from trade(% of GDP) in South Africa in 1997 to that in 1999?
Provide a succinct answer. 1.07. What is the ratio of the Earning from trade(% of GDP) in Sub-Saharan Africa (all income levels) in 1998 to that in 1999?
Your response must be concise. 0.99. What is the ratio of the Earning from trade(% of GDP) in Colombia in 1998 to that in 1999?
Ensure brevity in your answer.  1. What is the ratio of the Earning from trade(% of GDP) in South Africa in 1998 to that in 1999?
Keep it short and to the point. 1.03. What is the difference between the highest and the second highest Earning from trade(% of GDP) in Sub-Saharan Africa (all income levels)?
Make the answer very short. 0.6. What is the difference between the highest and the second highest Earning from trade(% of GDP) of Colombia?
Provide a short and direct response. 3.11. What is the difference between the highest and the second highest Earning from trade(% of GDP) in South Africa?
Your answer should be compact. 1.6. What is the difference between the highest and the lowest Earning from trade(% of GDP) of Sub-Saharan Africa (all income levels)?
Your answer should be compact. 7.44. What is the difference between the highest and the lowest Earning from trade(% of GDP) in Colombia?
Provide a short and direct response. 5.52. What is the difference between the highest and the lowest Earning from trade(% of GDP) in South Africa?
Your response must be concise. 9.04. 